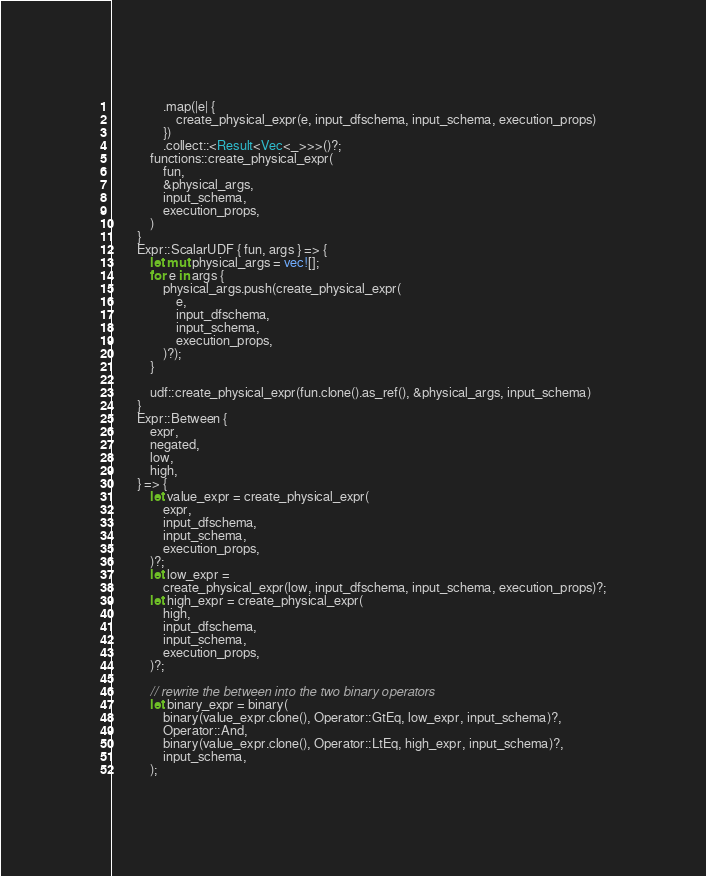<code> <loc_0><loc_0><loc_500><loc_500><_Rust_>                .map(|e| {
                    create_physical_expr(e, input_dfschema, input_schema, execution_props)
                })
                .collect::<Result<Vec<_>>>()?;
            functions::create_physical_expr(
                fun,
                &physical_args,
                input_schema,
                execution_props,
            )
        }
        Expr::ScalarUDF { fun, args } => {
            let mut physical_args = vec![];
            for e in args {
                physical_args.push(create_physical_expr(
                    e,
                    input_dfschema,
                    input_schema,
                    execution_props,
                )?);
            }

            udf::create_physical_expr(fun.clone().as_ref(), &physical_args, input_schema)
        }
        Expr::Between {
            expr,
            negated,
            low,
            high,
        } => {
            let value_expr = create_physical_expr(
                expr,
                input_dfschema,
                input_schema,
                execution_props,
            )?;
            let low_expr =
                create_physical_expr(low, input_dfschema, input_schema, execution_props)?;
            let high_expr = create_physical_expr(
                high,
                input_dfschema,
                input_schema,
                execution_props,
            )?;

            // rewrite the between into the two binary operators
            let binary_expr = binary(
                binary(value_expr.clone(), Operator::GtEq, low_expr, input_schema)?,
                Operator::And,
                binary(value_expr.clone(), Operator::LtEq, high_expr, input_schema)?,
                input_schema,
            );
</code> 